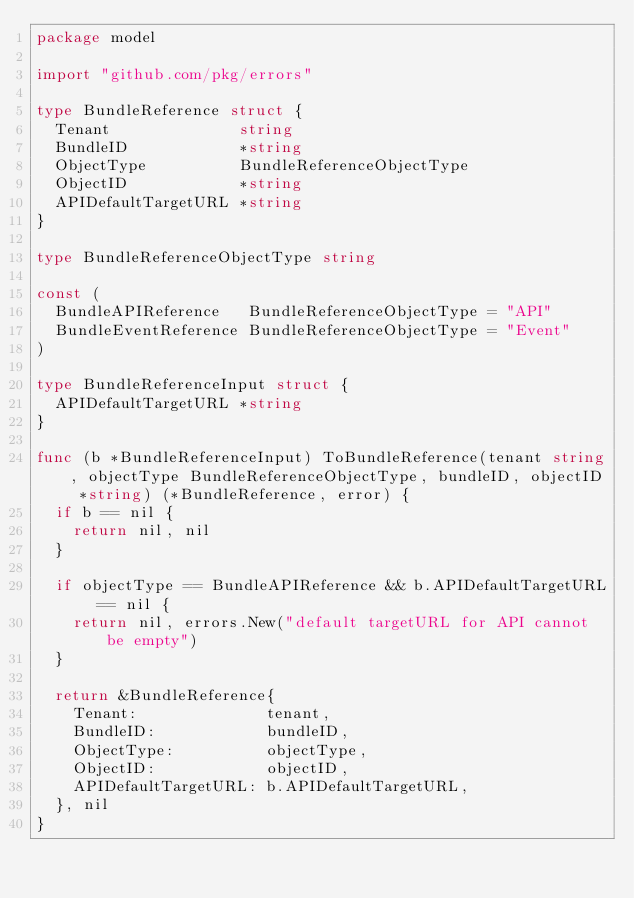<code> <loc_0><loc_0><loc_500><loc_500><_Go_>package model

import "github.com/pkg/errors"

type BundleReference struct {
	Tenant              string
	BundleID            *string
	ObjectType          BundleReferenceObjectType
	ObjectID            *string
	APIDefaultTargetURL *string
}

type BundleReferenceObjectType string

const (
	BundleAPIReference   BundleReferenceObjectType = "API"
	BundleEventReference BundleReferenceObjectType = "Event"
)

type BundleReferenceInput struct {
	APIDefaultTargetURL *string
}

func (b *BundleReferenceInput) ToBundleReference(tenant string, objectType BundleReferenceObjectType, bundleID, objectID *string) (*BundleReference, error) {
	if b == nil {
		return nil, nil
	}

	if objectType == BundleAPIReference && b.APIDefaultTargetURL == nil {
		return nil, errors.New("default targetURL for API cannot be empty")
	}

	return &BundleReference{
		Tenant:              tenant,
		BundleID:            bundleID,
		ObjectType:          objectType,
		ObjectID:            objectID,
		APIDefaultTargetURL: b.APIDefaultTargetURL,
	}, nil
}
</code> 